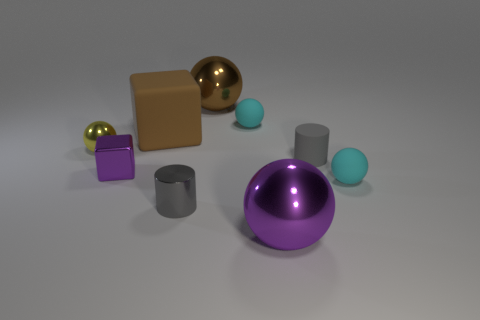Is there anything else that has the same size as the purple shiny cube?
Keep it short and to the point. Yes. What is the size of the purple thing that is the same shape as the small yellow metallic thing?
Ensure brevity in your answer.  Large. Are there more tiny yellow metallic cylinders than big metal things?
Give a very brief answer. No. Is the small gray rubber thing the same shape as the large purple object?
Keep it short and to the point. No. The big purple sphere on the left side of the tiny gray cylinder that is right of the tiny gray shiny thing is made of what material?
Offer a very short reply. Metal. There is a big object that is the same color as the large block; what material is it?
Your answer should be compact. Metal. Do the yellow ball and the gray matte cylinder have the same size?
Offer a very short reply. Yes. Is there a small metal cylinder on the left side of the purple thing behind the small gray shiny thing?
Make the answer very short. No. What is the size of the metal ball that is the same color as the rubber cube?
Make the answer very short. Large. There is a thing left of the small purple cube; what shape is it?
Provide a short and direct response. Sphere. 